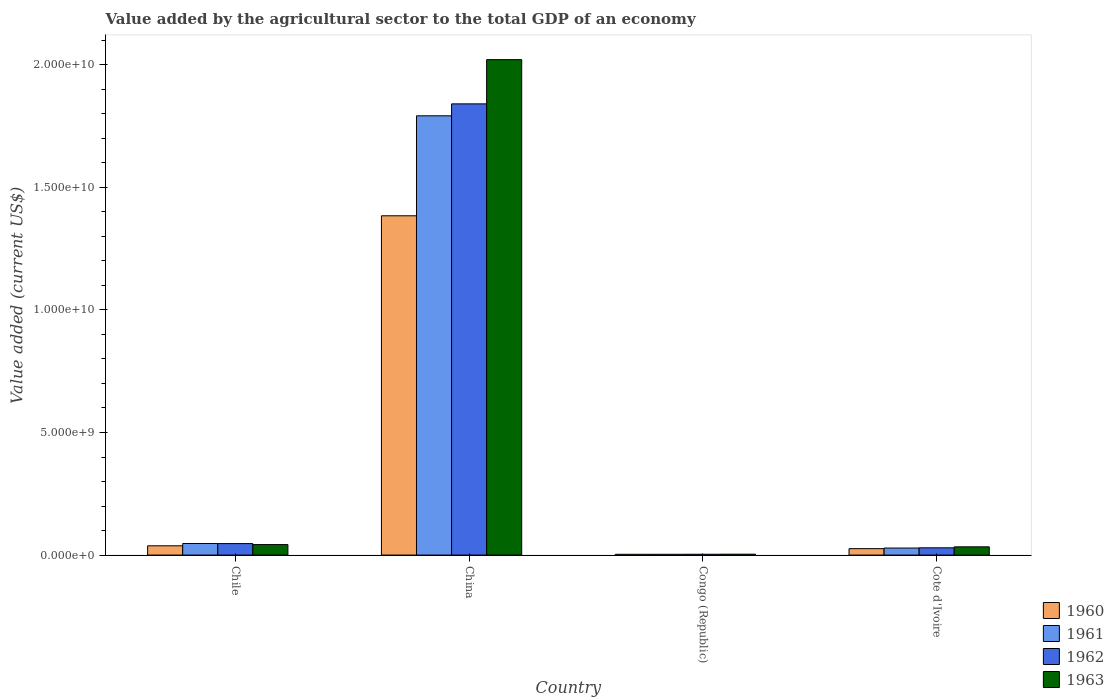Are the number of bars per tick equal to the number of legend labels?
Your response must be concise. Yes. How many bars are there on the 3rd tick from the right?
Your answer should be compact. 4. What is the label of the 3rd group of bars from the left?
Provide a succinct answer. Congo (Republic). What is the value added by the agricultural sector to the total GDP in 1960 in Congo (Republic)?
Give a very brief answer. 3.11e+07. Across all countries, what is the maximum value added by the agricultural sector to the total GDP in 1962?
Offer a very short reply. 1.84e+1. Across all countries, what is the minimum value added by the agricultural sector to the total GDP in 1960?
Offer a very short reply. 3.11e+07. In which country was the value added by the agricultural sector to the total GDP in 1962 maximum?
Offer a terse response. China. In which country was the value added by the agricultural sector to the total GDP in 1961 minimum?
Offer a very short reply. Congo (Republic). What is the total value added by the agricultural sector to the total GDP in 1962 in the graph?
Your answer should be very brief. 1.92e+1. What is the difference between the value added by the agricultural sector to the total GDP in 1963 in Congo (Republic) and that in Cote d'Ivoire?
Ensure brevity in your answer.  -3.00e+08. What is the difference between the value added by the agricultural sector to the total GDP in 1962 in Congo (Republic) and the value added by the agricultural sector to the total GDP in 1963 in China?
Give a very brief answer. -2.02e+1. What is the average value added by the agricultural sector to the total GDP in 1962 per country?
Your answer should be very brief. 4.80e+09. What is the difference between the value added by the agricultural sector to the total GDP of/in 1962 and value added by the agricultural sector to the total GDP of/in 1961 in Congo (Republic)?
Your response must be concise. 1.90e+06. In how many countries, is the value added by the agricultural sector to the total GDP in 1961 greater than 11000000000 US$?
Provide a succinct answer. 1. What is the ratio of the value added by the agricultural sector to the total GDP in 1963 in Chile to that in Congo (Republic)?
Make the answer very short. 11.86. What is the difference between the highest and the second highest value added by the agricultural sector to the total GDP in 1963?
Provide a succinct answer. 1.99e+1. What is the difference between the highest and the lowest value added by the agricultural sector to the total GDP in 1962?
Keep it short and to the point. 1.84e+1. Is the sum of the value added by the agricultural sector to the total GDP in 1960 in China and Cote d'Ivoire greater than the maximum value added by the agricultural sector to the total GDP in 1961 across all countries?
Give a very brief answer. No. Is it the case that in every country, the sum of the value added by the agricultural sector to the total GDP in 1962 and value added by the agricultural sector to the total GDP in 1961 is greater than the sum of value added by the agricultural sector to the total GDP in 1963 and value added by the agricultural sector to the total GDP in 1960?
Ensure brevity in your answer.  No. What does the 3rd bar from the right in Cote d'Ivoire represents?
Ensure brevity in your answer.  1961. How many bars are there?
Your response must be concise. 16. Are all the bars in the graph horizontal?
Your response must be concise. No. How many countries are there in the graph?
Provide a succinct answer. 4. What is the difference between two consecutive major ticks on the Y-axis?
Give a very brief answer. 5.00e+09. Does the graph contain any zero values?
Your answer should be compact. No. Where does the legend appear in the graph?
Provide a short and direct response. Bottom right. How are the legend labels stacked?
Ensure brevity in your answer.  Vertical. What is the title of the graph?
Offer a terse response. Value added by the agricultural sector to the total GDP of an economy. Does "1982" appear as one of the legend labels in the graph?
Offer a very short reply. No. What is the label or title of the Y-axis?
Provide a short and direct response. Value added (current US$). What is the Value added (current US$) in 1960 in Chile?
Your answer should be compact. 3.78e+08. What is the Value added (current US$) of 1961 in Chile?
Provide a succinct answer. 4.72e+08. What is the Value added (current US$) of 1962 in Chile?
Give a very brief answer. 4.69e+08. What is the Value added (current US$) of 1963 in Chile?
Provide a succinct answer. 4.28e+08. What is the Value added (current US$) in 1960 in China?
Offer a very short reply. 1.38e+1. What is the Value added (current US$) in 1961 in China?
Offer a terse response. 1.79e+1. What is the Value added (current US$) of 1962 in China?
Provide a succinct answer. 1.84e+1. What is the Value added (current US$) in 1963 in China?
Offer a terse response. 2.02e+1. What is the Value added (current US$) of 1960 in Congo (Republic)?
Make the answer very short. 3.11e+07. What is the Value added (current US$) in 1961 in Congo (Republic)?
Provide a short and direct response. 3.11e+07. What is the Value added (current US$) in 1962 in Congo (Republic)?
Keep it short and to the point. 3.30e+07. What is the Value added (current US$) in 1963 in Congo (Republic)?
Your answer should be compact. 3.61e+07. What is the Value added (current US$) of 1960 in Cote d'Ivoire?
Give a very brief answer. 2.62e+08. What is the Value added (current US$) in 1961 in Cote d'Ivoire?
Make the answer very short. 2.87e+08. What is the Value added (current US$) in 1962 in Cote d'Ivoire?
Provide a succinct answer. 2.96e+08. What is the Value added (current US$) in 1963 in Cote d'Ivoire?
Make the answer very short. 3.36e+08. Across all countries, what is the maximum Value added (current US$) in 1960?
Ensure brevity in your answer.  1.38e+1. Across all countries, what is the maximum Value added (current US$) of 1961?
Offer a very short reply. 1.79e+1. Across all countries, what is the maximum Value added (current US$) in 1962?
Make the answer very short. 1.84e+1. Across all countries, what is the maximum Value added (current US$) of 1963?
Your answer should be very brief. 2.02e+1. Across all countries, what is the minimum Value added (current US$) in 1960?
Your answer should be very brief. 3.11e+07. Across all countries, what is the minimum Value added (current US$) of 1961?
Your response must be concise. 3.11e+07. Across all countries, what is the minimum Value added (current US$) in 1962?
Ensure brevity in your answer.  3.30e+07. Across all countries, what is the minimum Value added (current US$) of 1963?
Provide a succinct answer. 3.61e+07. What is the total Value added (current US$) in 1960 in the graph?
Give a very brief answer. 1.45e+1. What is the total Value added (current US$) of 1961 in the graph?
Your answer should be compact. 1.87e+1. What is the total Value added (current US$) of 1962 in the graph?
Provide a succinct answer. 1.92e+1. What is the total Value added (current US$) of 1963 in the graph?
Offer a terse response. 2.10e+1. What is the difference between the Value added (current US$) in 1960 in Chile and that in China?
Give a very brief answer. -1.35e+1. What is the difference between the Value added (current US$) of 1961 in Chile and that in China?
Provide a short and direct response. -1.74e+1. What is the difference between the Value added (current US$) of 1962 in Chile and that in China?
Your answer should be compact. -1.79e+1. What is the difference between the Value added (current US$) in 1963 in Chile and that in China?
Make the answer very short. -1.98e+1. What is the difference between the Value added (current US$) of 1960 in Chile and that in Congo (Republic)?
Your response must be concise. 3.47e+08. What is the difference between the Value added (current US$) in 1961 in Chile and that in Congo (Republic)?
Offer a very short reply. 4.41e+08. What is the difference between the Value added (current US$) of 1962 in Chile and that in Congo (Republic)?
Offer a terse response. 4.36e+08. What is the difference between the Value added (current US$) in 1963 in Chile and that in Congo (Republic)?
Your answer should be compact. 3.92e+08. What is the difference between the Value added (current US$) of 1960 in Chile and that in Cote d'Ivoire?
Your answer should be very brief. 1.16e+08. What is the difference between the Value added (current US$) in 1961 in Chile and that in Cote d'Ivoire?
Keep it short and to the point. 1.85e+08. What is the difference between the Value added (current US$) of 1962 in Chile and that in Cote d'Ivoire?
Keep it short and to the point. 1.72e+08. What is the difference between the Value added (current US$) in 1963 in Chile and that in Cote d'Ivoire?
Offer a very short reply. 9.18e+07. What is the difference between the Value added (current US$) in 1960 in China and that in Congo (Republic)?
Make the answer very short. 1.38e+1. What is the difference between the Value added (current US$) in 1961 in China and that in Congo (Republic)?
Your answer should be compact. 1.79e+1. What is the difference between the Value added (current US$) in 1962 in China and that in Congo (Republic)?
Make the answer very short. 1.84e+1. What is the difference between the Value added (current US$) in 1963 in China and that in Congo (Republic)?
Provide a succinct answer. 2.02e+1. What is the difference between the Value added (current US$) in 1960 in China and that in Cote d'Ivoire?
Make the answer very short. 1.36e+1. What is the difference between the Value added (current US$) in 1961 in China and that in Cote d'Ivoire?
Your response must be concise. 1.76e+1. What is the difference between the Value added (current US$) of 1962 in China and that in Cote d'Ivoire?
Keep it short and to the point. 1.81e+1. What is the difference between the Value added (current US$) of 1963 in China and that in Cote d'Ivoire?
Make the answer very short. 1.99e+1. What is the difference between the Value added (current US$) of 1960 in Congo (Republic) and that in Cote d'Ivoire?
Make the answer very short. -2.31e+08. What is the difference between the Value added (current US$) of 1961 in Congo (Republic) and that in Cote d'Ivoire?
Give a very brief answer. -2.56e+08. What is the difference between the Value added (current US$) of 1962 in Congo (Republic) and that in Cote d'Ivoire?
Provide a short and direct response. -2.63e+08. What is the difference between the Value added (current US$) in 1963 in Congo (Republic) and that in Cote d'Ivoire?
Your answer should be very brief. -3.00e+08. What is the difference between the Value added (current US$) of 1960 in Chile and the Value added (current US$) of 1961 in China?
Provide a succinct answer. -1.75e+1. What is the difference between the Value added (current US$) of 1960 in Chile and the Value added (current US$) of 1962 in China?
Your answer should be compact. -1.80e+1. What is the difference between the Value added (current US$) in 1960 in Chile and the Value added (current US$) in 1963 in China?
Provide a succinct answer. -1.98e+1. What is the difference between the Value added (current US$) of 1961 in Chile and the Value added (current US$) of 1962 in China?
Give a very brief answer. -1.79e+1. What is the difference between the Value added (current US$) of 1961 in Chile and the Value added (current US$) of 1963 in China?
Your response must be concise. -1.97e+1. What is the difference between the Value added (current US$) in 1962 in Chile and the Value added (current US$) in 1963 in China?
Your response must be concise. -1.97e+1. What is the difference between the Value added (current US$) in 1960 in Chile and the Value added (current US$) in 1961 in Congo (Republic)?
Make the answer very short. 3.47e+08. What is the difference between the Value added (current US$) of 1960 in Chile and the Value added (current US$) of 1962 in Congo (Republic)?
Make the answer very short. 3.45e+08. What is the difference between the Value added (current US$) of 1960 in Chile and the Value added (current US$) of 1963 in Congo (Republic)?
Offer a very short reply. 3.42e+08. What is the difference between the Value added (current US$) of 1961 in Chile and the Value added (current US$) of 1962 in Congo (Republic)?
Ensure brevity in your answer.  4.39e+08. What is the difference between the Value added (current US$) of 1961 in Chile and the Value added (current US$) of 1963 in Congo (Republic)?
Your response must be concise. 4.36e+08. What is the difference between the Value added (current US$) in 1962 in Chile and the Value added (current US$) in 1963 in Congo (Republic)?
Offer a terse response. 4.33e+08. What is the difference between the Value added (current US$) in 1960 in Chile and the Value added (current US$) in 1961 in Cote d'Ivoire?
Offer a terse response. 9.12e+07. What is the difference between the Value added (current US$) in 1960 in Chile and the Value added (current US$) in 1962 in Cote d'Ivoire?
Your answer should be compact. 8.19e+07. What is the difference between the Value added (current US$) of 1960 in Chile and the Value added (current US$) of 1963 in Cote d'Ivoire?
Give a very brief answer. 4.20e+07. What is the difference between the Value added (current US$) of 1961 in Chile and the Value added (current US$) of 1962 in Cote d'Ivoire?
Your response must be concise. 1.76e+08. What is the difference between the Value added (current US$) of 1961 in Chile and the Value added (current US$) of 1963 in Cote d'Ivoire?
Offer a terse response. 1.36e+08. What is the difference between the Value added (current US$) in 1962 in Chile and the Value added (current US$) in 1963 in Cote d'Ivoire?
Offer a terse response. 1.32e+08. What is the difference between the Value added (current US$) of 1960 in China and the Value added (current US$) of 1961 in Congo (Republic)?
Your answer should be compact. 1.38e+1. What is the difference between the Value added (current US$) in 1960 in China and the Value added (current US$) in 1962 in Congo (Republic)?
Offer a very short reply. 1.38e+1. What is the difference between the Value added (current US$) of 1960 in China and the Value added (current US$) of 1963 in Congo (Republic)?
Offer a terse response. 1.38e+1. What is the difference between the Value added (current US$) in 1961 in China and the Value added (current US$) in 1962 in Congo (Republic)?
Your answer should be very brief. 1.79e+1. What is the difference between the Value added (current US$) in 1961 in China and the Value added (current US$) in 1963 in Congo (Republic)?
Your answer should be very brief. 1.79e+1. What is the difference between the Value added (current US$) in 1962 in China and the Value added (current US$) in 1963 in Congo (Republic)?
Provide a succinct answer. 1.84e+1. What is the difference between the Value added (current US$) of 1960 in China and the Value added (current US$) of 1961 in Cote d'Ivoire?
Give a very brief answer. 1.36e+1. What is the difference between the Value added (current US$) of 1960 in China and the Value added (current US$) of 1962 in Cote d'Ivoire?
Keep it short and to the point. 1.35e+1. What is the difference between the Value added (current US$) of 1960 in China and the Value added (current US$) of 1963 in Cote d'Ivoire?
Provide a short and direct response. 1.35e+1. What is the difference between the Value added (current US$) in 1961 in China and the Value added (current US$) in 1962 in Cote d'Ivoire?
Offer a terse response. 1.76e+1. What is the difference between the Value added (current US$) in 1961 in China and the Value added (current US$) in 1963 in Cote d'Ivoire?
Offer a terse response. 1.76e+1. What is the difference between the Value added (current US$) of 1962 in China and the Value added (current US$) of 1963 in Cote d'Ivoire?
Provide a short and direct response. 1.81e+1. What is the difference between the Value added (current US$) in 1960 in Congo (Republic) and the Value added (current US$) in 1961 in Cote d'Ivoire?
Ensure brevity in your answer.  -2.56e+08. What is the difference between the Value added (current US$) of 1960 in Congo (Republic) and the Value added (current US$) of 1962 in Cote d'Ivoire?
Make the answer very short. -2.65e+08. What is the difference between the Value added (current US$) in 1960 in Congo (Republic) and the Value added (current US$) in 1963 in Cote d'Ivoire?
Make the answer very short. -3.05e+08. What is the difference between the Value added (current US$) of 1961 in Congo (Republic) and the Value added (current US$) of 1962 in Cote d'Ivoire?
Your answer should be very brief. -2.65e+08. What is the difference between the Value added (current US$) of 1961 in Congo (Republic) and the Value added (current US$) of 1963 in Cote d'Ivoire?
Offer a terse response. -3.05e+08. What is the difference between the Value added (current US$) of 1962 in Congo (Republic) and the Value added (current US$) of 1963 in Cote d'Ivoire?
Offer a very short reply. -3.03e+08. What is the average Value added (current US$) of 1960 per country?
Make the answer very short. 3.63e+09. What is the average Value added (current US$) in 1961 per country?
Your answer should be compact. 4.68e+09. What is the average Value added (current US$) in 1962 per country?
Provide a succinct answer. 4.80e+09. What is the average Value added (current US$) of 1963 per country?
Your answer should be compact. 5.25e+09. What is the difference between the Value added (current US$) of 1960 and Value added (current US$) of 1961 in Chile?
Give a very brief answer. -9.41e+07. What is the difference between the Value added (current US$) in 1960 and Value added (current US$) in 1962 in Chile?
Your response must be concise. -9.05e+07. What is the difference between the Value added (current US$) in 1960 and Value added (current US$) in 1963 in Chile?
Provide a short and direct response. -4.98e+07. What is the difference between the Value added (current US$) in 1961 and Value added (current US$) in 1962 in Chile?
Your response must be concise. 3.57e+06. What is the difference between the Value added (current US$) of 1961 and Value added (current US$) of 1963 in Chile?
Offer a terse response. 4.42e+07. What is the difference between the Value added (current US$) in 1962 and Value added (current US$) in 1963 in Chile?
Give a very brief answer. 4.07e+07. What is the difference between the Value added (current US$) in 1960 and Value added (current US$) in 1961 in China?
Make the answer very short. -4.08e+09. What is the difference between the Value added (current US$) of 1960 and Value added (current US$) of 1962 in China?
Ensure brevity in your answer.  -4.57e+09. What is the difference between the Value added (current US$) of 1960 and Value added (current US$) of 1963 in China?
Make the answer very short. -6.37e+09. What is the difference between the Value added (current US$) in 1961 and Value added (current US$) in 1962 in China?
Give a very brief answer. -4.87e+08. What is the difference between the Value added (current US$) in 1961 and Value added (current US$) in 1963 in China?
Provide a short and direct response. -2.29e+09. What is the difference between the Value added (current US$) of 1962 and Value added (current US$) of 1963 in China?
Keep it short and to the point. -1.80e+09. What is the difference between the Value added (current US$) of 1960 and Value added (current US$) of 1961 in Congo (Republic)?
Make the answer very short. 8239.47. What is the difference between the Value added (current US$) in 1960 and Value added (current US$) in 1962 in Congo (Republic)?
Your response must be concise. -1.89e+06. What is the difference between the Value added (current US$) of 1960 and Value added (current US$) of 1963 in Congo (Republic)?
Provide a succinct answer. -5.00e+06. What is the difference between the Value added (current US$) of 1961 and Value added (current US$) of 1962 in Congo (Republic)?
Provide a short and direct response. -1.90e+06. What is the difference between the Value added (current US$) in 1961 and Value added (current US$) in 1963 in Congo (Republic)?
Your response must be concise. -5.01e+06. What is the difference between the Value added (current US$) of 1962 and Value added (current US$) of 1963 in Congo (Republic)?
Provide a short and direct response. -3.11e+06. What is the difference between the Value added (current US$) of 1960 and Value added (current US$) of 1961 in Cote d'Ivoire?
Offer a very short reply. -2.52e+07. What is the difference between the Value added (current US$) of 1960 and Value added (current US$) of 1962 in Cote d'Ivoire?
Provide a short and direct response. -3.45e+07. What is the difference between the Value added (current US$) in 1960 and Value added (current US$) in 1963 in Cote d'Ivoire?
Offer a very short reply. -7.45e+07. What is the difference between the Value added (current US$) in 1961 and Value added (current US$) in 1962 in Cote d'Ivoire?
Ensure brevity in your answer.  -9.30e+06. What is the difference between the Value added (current US$) of 1961 and Value added (current US$) of 1963 in Cote d'Ivoire?
Make the answer very short. -4.92e+07. What is the difference between the Value added (current US$) in 1962 and Value added (current US$) in 1963 in Cote d'Ivoire?
Offer a terse response. -3.99e+07. What is the ratio of the Value added (current US$) in 1960 in Chile to that in China?
Offer a very short reply. 0.03. What is the ratio of the Value added (current US$) in 1961 in Chile to that in China?
Your answer should be very brief. 0.03. What is the ratio of the Value added (current US$) in 1962 in Chile to that in China?
Provide a short and direct response. 0.03. What is the ratio of the Value added (current US$) of 1963 in Chile to that in China?
Offer a terse response. 0.02. What is the ratio of the Value added (current US$) of 1960 in Chile to that in Congo (Republic)?
Your answer should be compact. 12.16. What is the ratio of the Value added (current US$) of 1961 in Chile to that in Congo (Republic)?
Provide a short and direct response. 15.19. What is the ratio of the Value added (current US$) in 1962 in Chile to that in Congo (Republic)?
Make the answer very short. 14.21. What is the ratio of the Value added (current US$) of 1963 in Chile to that in Congo (Republic)?
Keep it short and to the point. 11.86. What is the ratio of the Value added (current US$) of 1960 in Chile to that in Cote d'Ivoire?
Offer a very short reply. 1.44. What is the ratio of the Value added (current US$) in 1961 in Chile to that in Cote d'Ivoire?
Make the answer very short. 1.65. What is the ratio of the Value added (current US$) of 1962 in Chile to that in Cote d'Ivoire?
Make the answer very short. 1.58. What is the ratio of the Value added (current US$) of 1963 in Chile to that in Cote d'Ivoire?
Make the answer very short. 1.27. What is the ratio of the Value added (current US$) in 1960 in China to that in Congo (Republic)?
Ensure brevity in your answer.  445.15. What is the ratio of the Value added (current US$) of 1961 in China to that in Congo (Republic)?
Make the answer very short. 576.48. What is the ratio of the Value added (current US$) in 1962 in China to that in Congo (Republic)?
Offer a terse response. 558.09. What is the ratio of the Value added (current US$) in 1963 in China to that in Congo (Republic)?
Your answer should be very brief. 559.95. What is the ratio of the Value added (current US$) in 1960 in China to that in Cote d'Ivoire?
Ensure brevity in your answer.  52.89. What is the ratio of the Value added (current US$) in 1961 in China to that in Cote d'Ivoire?
Provide a succinct answer. 62.45. What is the ratio of the Value added (current US$) of 1962 in China to that in Cote d'Ivoire?
Make the answer very short. 62.14. What is the ratio of the Value added (current US$) of 1963 in China to that in Cote d'Ivoire?
Provide a succinct answer. 60.12. What is the ratio of the Value added (current US$) in 1960 in Congo (Republic) to that in Cote d'Ivoire?
Your answer should be compact. 0.12. What is the ratio of the Value added (current US$) of 1961 in Congo (Republic) to that in Cote d'Ivoire?
Your answer should be very brief. 0.11. What is the ratio of the Value added (current US$) in 1962 in Congo (Republic) to that in Cote d'Ivoire?
Offer a terse response. 0.11. What is the ratio of the Value added (current US$) of 1963 in Congo (Republic) to that in Cote d'Ivoire?
Your answer should be very brief. 0.11. What is the difference between the highest and the second highest Value added (current US$) in 1960?
Ensure brevity in your answer.  1.35e+1. What is the difference between the highest and the second highest Value added (current US$) in 1961?
Offer a very short reply. 1.74e+1. What is the difference between the highest and the second highest Value added (current US$) in 1962?
Ensure brevity in your answer.  1.79e+1. What is the difference between the highest and the second highest Value added (current US$) in 1963?
Provide a short and direct response. 1.98e+1. What is the difference between the highest and the lowest Value added (current US$) of 1960?
Your answer should be compact. 1.38e+1. What is the difference between the highest and the lowest Value added (current US$) of 1961?
Offer a terse response. 1.79e+1. What is the difference between the highest and the lowest Value added (current US$) of 1962?
Offer a terse response. 1.84e+1. What is the difference between the highest and the lowest Value added (current US$) in 1963?
Provide a succinct answer. 2.02e+1. 